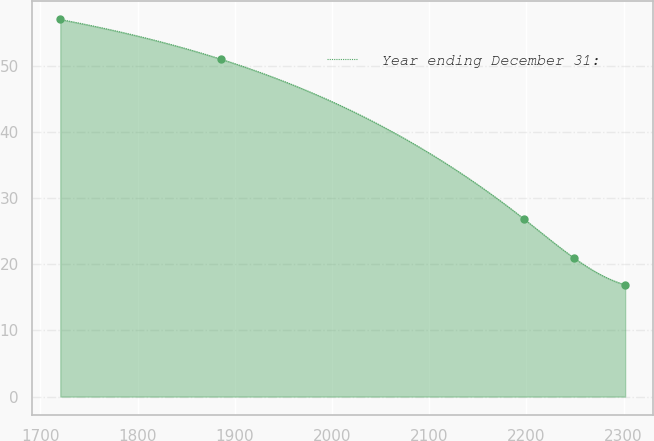<chart> <loc_0><loc_0><loc_500><loc_500><line_chart><ecel><fcel>Year ending December 31:<nl><fcel>1720.48<fcel>57.02<nl><fcel>1885.62<fcel>51.02<nl><fcel>2196.96<fcel>26.91<nl><fcel>2249.22<fcel>20.93<nl><fcel>2301.48<fcel>16.92<nl></chart> 